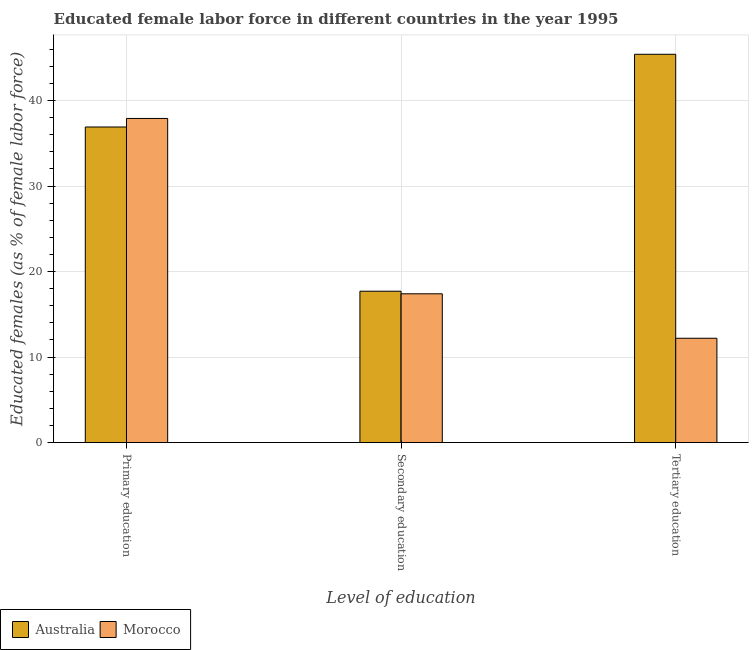How many different coloured bars are there?
Your answer should be compact. 2. How many bars are there on the 2nd tick from the left?
Offer a very short reply. 2. How many bars are there on the 1st tick from the right?
Offer a terse response. 2. What is the label of the 2nd group of bars from the left?
Offer a terse response. Secondary education. What is the percentage of female labor force who received primary education in Australia?
Offer a terse response. 36.9. Across all countries, what is the maximum percentage of female labor force who received tertiary education?
Your answer should be very brief. 45.4. Across all countries, what is the minimum percentage of female labor force who received secondary education?
Your response must be concise. 17.4. In which country was the percentage of female labor force who received tertiary education maximum?
Your answer should be very brief. Australia. In which country was the percentage of female labor force who received secondary education minimum?
Keep it short and to the point. Morocco. What is the total percentage of female labor force who received primary education in the graph?
Give a very brief answer. 74.8. What is the difference between the percentage of female labor force who received secondary education in Australia and that in Morocco?
Keep it short and to the point. 0.3. What is the difference between the percentage of female labor force who received primary education in Australia and the percentage of female labor force who received tertiary education in Morocco?
Keep it short and to the point. 24.7. What is the average percentage of female labor force who received primary education per country?
Offer a terse response. 37.4. What is the difference between the percentage of female labor force who received secondary education and percentage of female labor force who received primary education in Morocco?
Provide a succinct answer. -20.5. In how many countries, is the percentage of female labor force who received secondary education greater than 14 %?
Provide a succinct answer. 2. What is the ratio of the percentage of female labor force who received tertiary education in Australia to that in Morocco?
Your answer should be compact. 3.72. What is the difference between the highest and the second highest percentage of female labor force who received tertiary education?
Provide a short and direct response. 33.2. What is the difference between the highest and the lowest percentage of female labor force who received secondary education?
Your response must be concise. 0.3. In how many countries, is the percentage of female labor force who received secondary education greater than the average percentage of female labor force who received secondary education taken over all countries?
Provide a short and direct response. 1. What does the 1st bar from the right in Tertiary education represents?
Ensure brevity in your answer.  Morocco. Is it the case that in every country, the sum of the percentage of female labor force who received primary education and percentage of female labor force who received secondary education is greater than the percentage of female labor force who received tertiary education?
Your response must be concise. Yes. How many bars are there?
Keep it short and to the point. 6. What is the difference between two consecutive major ticks on the Y-axis?
Provide a short and direct response. 10. Does the graph contain any zero values?
Offer a very short reply. No. Where does the legend appear in the graph?
Your response must be concise. Bottom left. What is the title of the graph?
Offer a terse response. Educated female labor force in different countries in the year 1995. Does "Burundi" appear as one of the legend labels in the graph?
Provide a short and direct response. No. What is the label or title of the X-axis?
Your answer should be compact. Level of education. What is the label or title of the Y-axis?
Provide a short and direct response. Educated females (as % of female labor force). What is the Educated females (as % of female labor force) in Australia in Primary education?
Make the answer very short. 36.9. What is the Educated females (as % of female labor force) of Morocco in Primary education?
Your response must be concise. 37.9. What is the Educated females (as % of female labor force) of Australia in Secondary education?
Provide a short and direct response. 17.7. What is the Educated females (as % of female labor force) in Morocco in Secondary education?
Your response must be concise. 17.4. What is the Educated females (as % of female labor force) in Australia in Tertiary education?
Make the answer very short. 45.4. What is the Educated females (as % of female labor force) of Morocco in Tertiary education?
Ensure brevity in your answer.  12.2. Across all Level of education, what is the maximum Educated females (as % of female labor force) of Australia?
Provide a short and direct response. 45.4. Across all Level of education, what is the maximum Educated females (as % of female labor force) in Morocco?
Offer a terse response. 37.9. Across all Level of education, what is the minimum Educated females (as % of female labor force) in Australia?
Ensure brevity in your answer.  17.7. Across all Level of education, what is the minimum Educated females (as % of female labor force) in Morocco?
Offer a terse response. 12.2. What is the total Educated females (as % of female labor force) in Morocco in the graph?
Your answer should be compact. 67.5. What is the difference between the Educated females (as % of female labor force) of Australia in Primary education and that in Secondary education?
Your response must be concise. 19.2. What is the difference between the Educated females (as % of female labor force) of Morocco in Primary education and that in Tertiary education?
Ensure brevity in your answer.  25.7. What is the difference between the Educated females (as % of female labor force) of Australia in Secondary education and that in Tertiary education?
Your response must be concise. -27.7. What is the difference between the Educated females (as % of female labor force) of Morocco in Secondary education and that in Tertiary education?
Offer a terse response. 5.2. What is the difference between the Educated females (as % of female labor force) of Australia in Primary education and the Educated females (as % of female labor force) of Morocco in Secondary education?
Ensure brevity in your answer.  19.5. What is the difference between the Educated females (as % of female labor force) in Australia in Primary education and the Educated females (as % of female labor force) in Morocco in Tertiary education?
Offer a terse response. 24.7. What is the difference between the Educated females (as % of female labor force) in Australia in Secondary education and the Educated females (as % of female labor force) in Morocco in Tertiary education?
Give a very brief answer. 5.5. What is the average Educated females (as % of female labor force) in Australia per Level of education?
Give a very brief answer. 33.33. What is the difference between the Educated females (as % of female labor force) in Australia and Educated females (as % of female labor force) in Morocco in Secondary education?
Keep it short and to the point. 0.3. What is the difference between the Educated females (as % of female labor force) of Australia and Educated females (as % of female labor force) of Morocco in Tertiary education?
Make the answer very short. 33.2. What is the ratio of the Educated females (as % of female labor force) of Australia in Primary education to that in Secondary education?
Offer a very short reply. 2.08. What is the ratio of the Educated females (as % of female labor force) in Morocco in Primary education to that in Secondary education?
Ensure brevity in your answer.  2.18. What is the ratio of the Educated females (as % of female labor force) in Australia in Primary education to that in Tertiary education?
Provide a succinct answer. 0.81. What is the ratio of the Educated females (as % of female labor force) of Morocco in Primary education to that in Tertiary education?
Keep it short and to the point. 3.11. What is the ratio of the Educated females (as % of female labor force) in Australia in Secondary education to that in Tertiary education?
Your response must be concise. 0.39. What is the ratio of the Educated females (as % of female labor force) in Morocco in Secondary education to that in Tertiary education?
Keep it short and to the point. 1.43. What is the difference between the highest and the second highest Educated females (as % of female labor force) of Australia?
Make the answer very short. 8.5. What is the difference between the highest and the lowest Educated females (as % of female labor force) of Australia?
Offer a terse response. 27.7. What is the difference between the highest and the lowest Educated females (as % of female labor force) of Morocco?
Your answer should be compact. 25.7. 